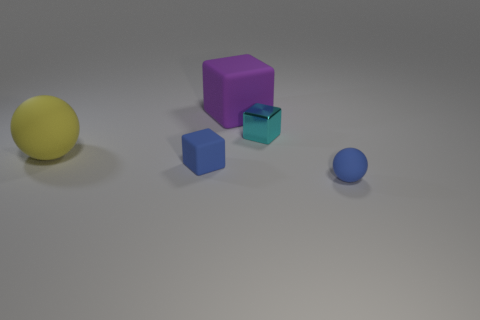Add 4 tiny matte cylinders. How many objects exist? 9 Subtract all spheres. How many objects are left? 3 Add 3 tiny metallic blocks. How many tiny metallic blocks are left? 4 Add 3 large metallic balls. How many large metallic balls exist? 3 Subtract 0 gray cubes. How many objects are left? 5 Subtract all small brown spheres. Subtract all cyan objects. How many objects are left? 4 